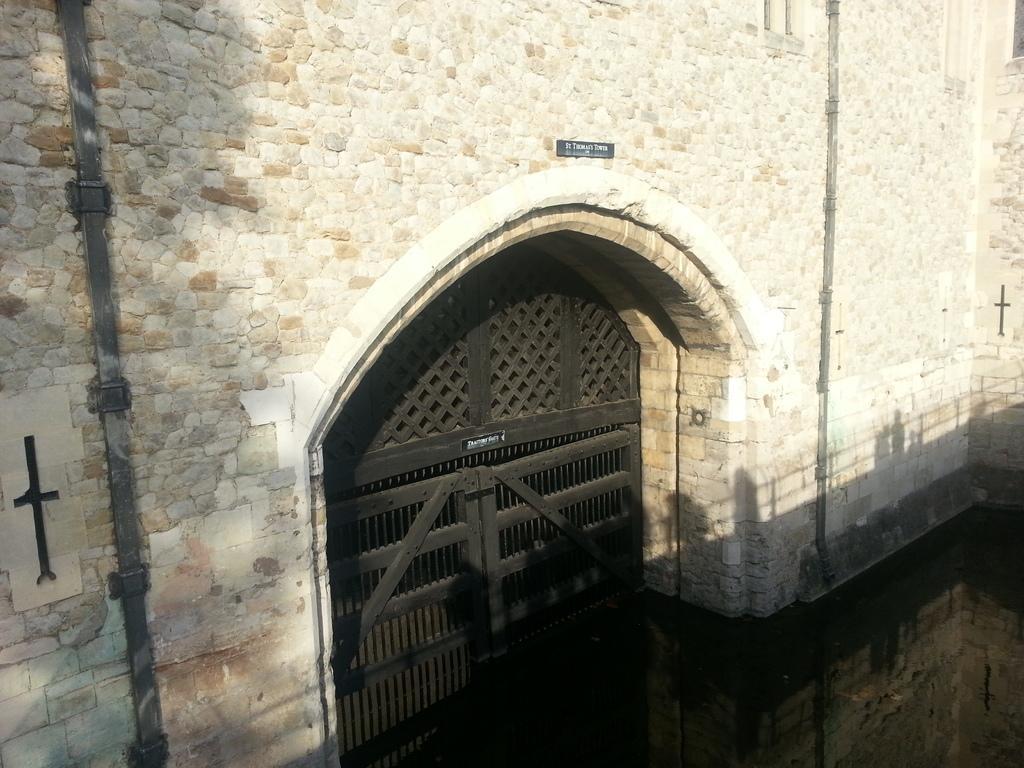Describe this image in one or two sentences. In this image we can see a building, on the building we can see a board with text, also we can see the doors and in front of the building we can see the water. 